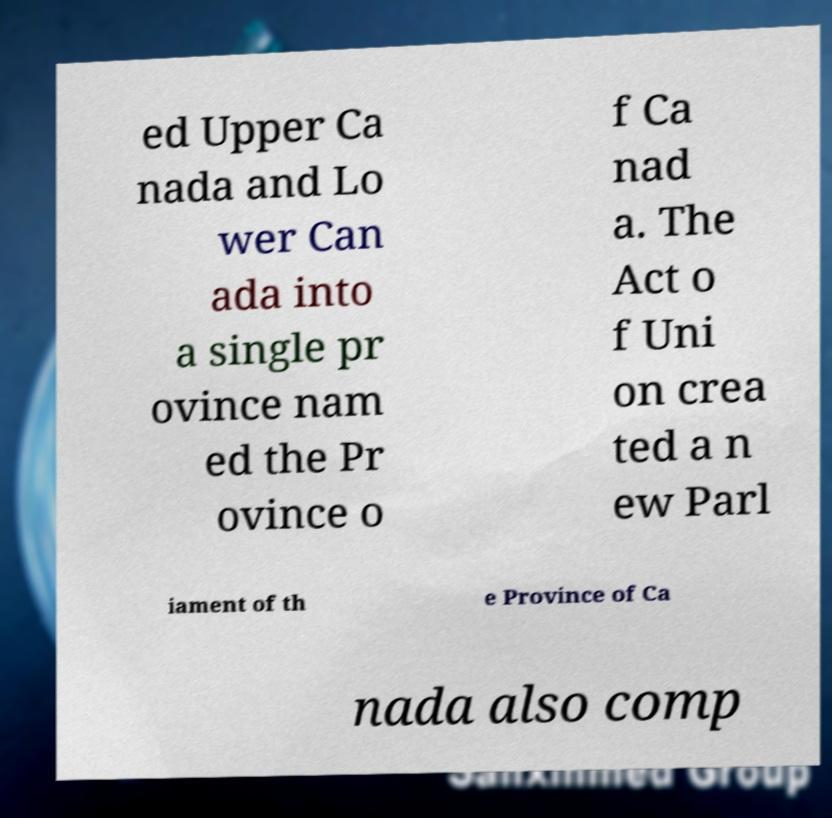Could you assist in decoding the text presented in this image and type it out clearly? ed Upper Ca nada and Lo wer Can ada into a single pr ovince nam ed the Pr ovince o f Ca nad a. The Act o f Uni on crea ted a n ew Parl iament of th e Province of Ca nada also comp 